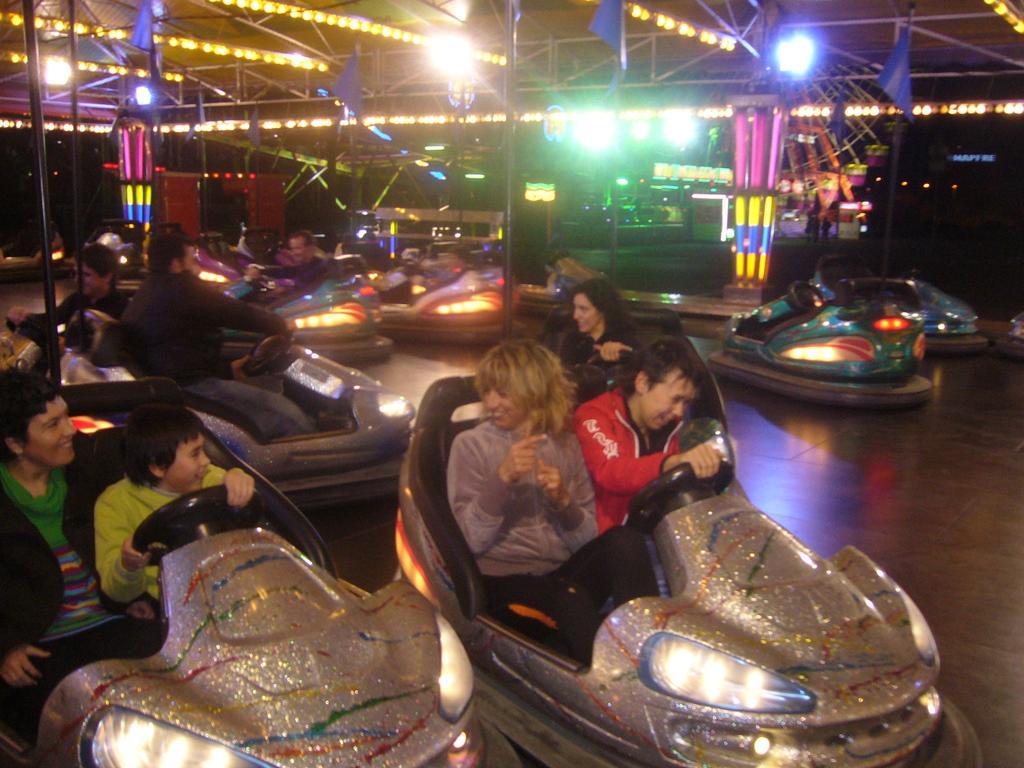Could you give a brief overview of what you see in this image? In this image there are bumper cars, there are persons sitting in the bumper cars, there is floor towards the right of the image, there are poles, there are lights, there are flags towards the top of the image, there is roof towards the top of the image. 